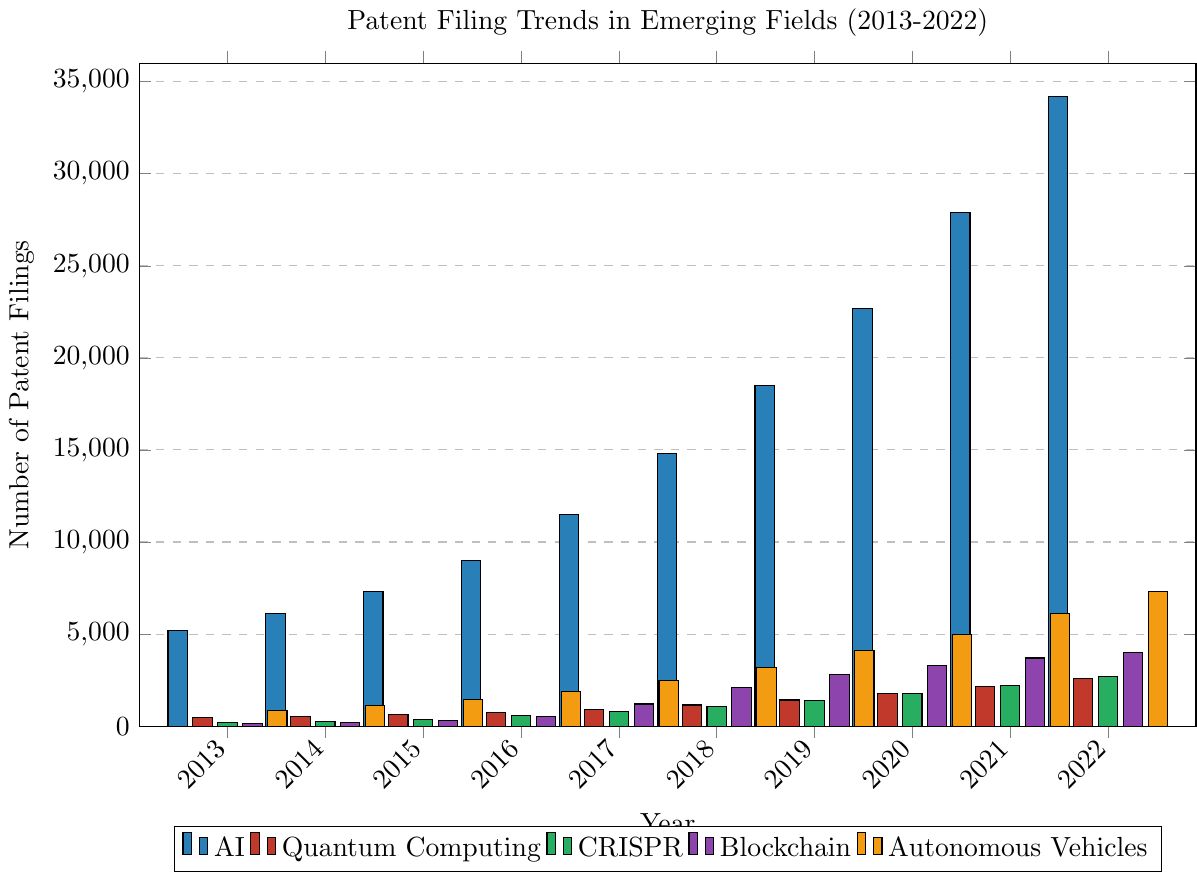Which emerging field saw the most significant increase in patent filings between 2013 and 2022? To find the field with the most significant increase, calculate the difference in patent filings between 2013 and 2022 for each field:
- AI: 34200 - 5200 = 29000
- Quantum Computing: 2600 - 450 = 2150
- CRISPR: 2700 - 180 = 2520
- Blockchain: 4000 - 120 = 3880
- Autonomous Vehicles: 7300 - 850 = 6450
AI has the highest increase.
Answer: AI How did the number of AI patent filings in 2020 compare to the number of Blockchain patent filings in the same year? Compare the AI patent filings in 2020 (22700) with Blockchain patent filings in 2020 (3300):
- AI: 22700
- Blockchain: 3300
22700 is greater than 3300.
Answer: AI had more filings than Blockchain What is the average number of patent filings for CRISPR over the decade? To find the average, sum the CRISPR patent filings from 2013 to 2022 and divide by the number of years:
Total CRISPR filings: 180 + 250 + 380 + 560 + 780 + 1050 + 1380 + 1750 + 2200 + 2700 = 12230
Number of years: 10
Average = 12230 / 10
Answer: 1223 In which year did Autonomous Vehicles surpass 3000 patent filings, and what was the exact number of filings that year? Look at the Autonomous Vehicles data and find the first year with filings greater than 3000:
- 2018: 3200
The year is 2018, and the number of filings is 3200.
Answer: 2018, 3200 Which field had the least patent filings in 2019? Check the patent filings for 2019:
- AI: 18500
- Quantum Computing: 1420
- CRISPR: 1380
- Blockchain: 2800
- Autonomous Vehicles: 4100
CRISPR had the least filings.
Answer: CRISPR By how much did the patent filings for Quantum Computing increase from 2016 to 2017? Subtract the 2016 filings from the 2017 filings for Quantum Computing:
- 2017: 920
- 2016: 750
Increase = 920 - 750
Answer: 170 Compare the growth trend of AI and Blockchain patents from 2018 to 2022. Which field had more consistent growth? Calculate and compare the year-over-year increases for AI and Blockchain:
- AI: 
  - 2018 to 2019: 3700
  - 2019 to 2020: 4200
  - 2020 to 2021: 5200
  - 2021 to 2022: 6300
- Blockchain: 
  - 2018 to 2019: 700
  - 2019 to 2020: 500
  - 2020 to 2021: 400
  - 2021 to 2022: 300
AI had more consistent year-over-year growth.
Answer: AI had more consistent growth 